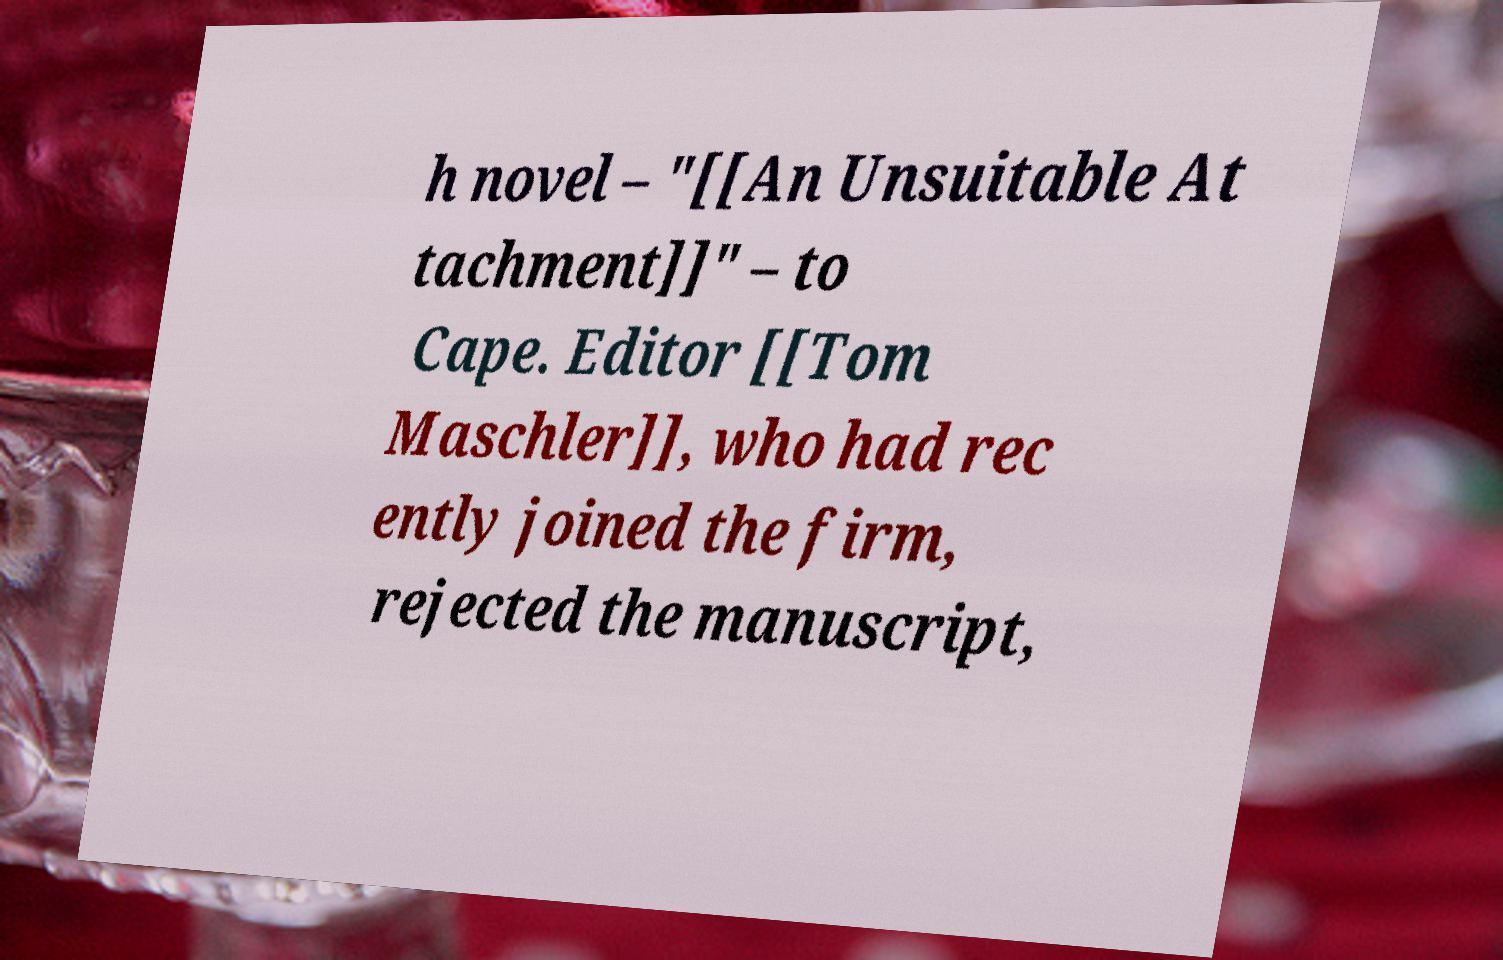There's text embedded in this image that I need extracted. Can you transcribe it verbatim? h novel – "[[An Unsuitable At tachment]]" – to Cape. Editor [[Tom Maschler]], who had rec ently joined the firm, rejected the manuscript, 